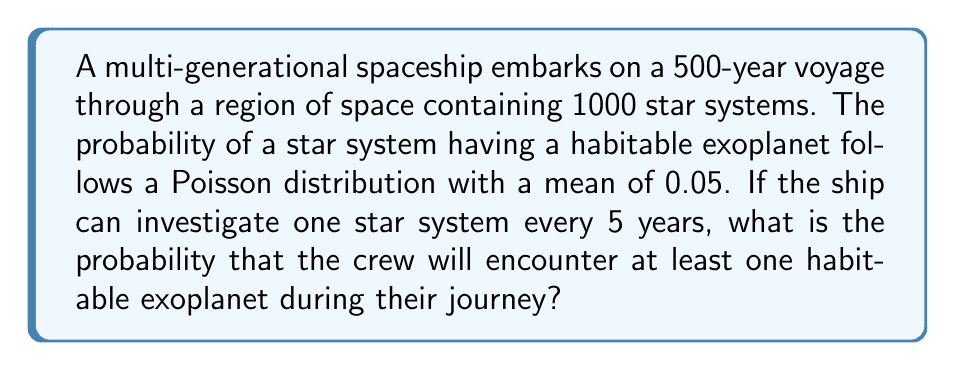What is the answer to this math problem? Let's approach this step-by-step:

1) First, we need to calculate how many star systems the ship can investigate during its 500-year journey:
   
   Number of systems = 500 years / 5 years per system = 100 systems

2) The probability of a star system having a habitable exoplanet follows a Poisson distribution with λ = 0.05. 

3) The probability of finding no habitable exoplanets in a single system is:

   $P(X = 0) = \frac{e^{-λ}λ^0}{0!} = e^{-0.05} ≈ 0.9512$

4) The probability of finding at least one habitable exoplanet in a single system is:

   $P(X ≥ 1) = 1 - P(X = 0) = 1 - 0.9512 = 0.0488$

5) Now, we need to calculate the probability of finding at least one habitable exoplanet in 100 independent trials. This is equivalent to calculating the probability of not finding zero habitable exoplanets in all 100 trials:

   $P(\text{at least one in 100 trials}) = 1 - P(\text{zero in all 100 trials})$
   
   $= 1 - (0.9512)^{100}$

6) Calculate:

   $1 - (0.9512)^{100} ≈ 1 - 0.0076 = 0.9924$

Therefore, the probability of encountering at least one habitable exoplanet during the 500-year journey is approximately 0.9924 or 99.24%.
Answer: 0.9924 